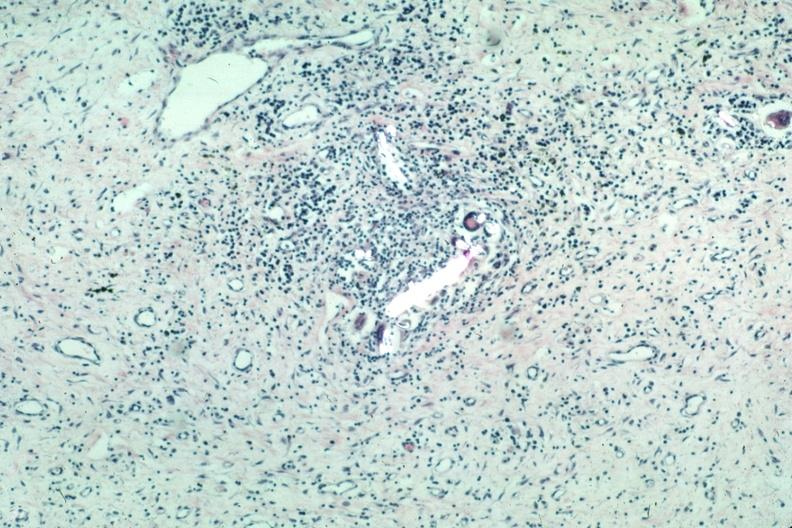s choanal patency present?
Answer the question using a single word or phrase. No 